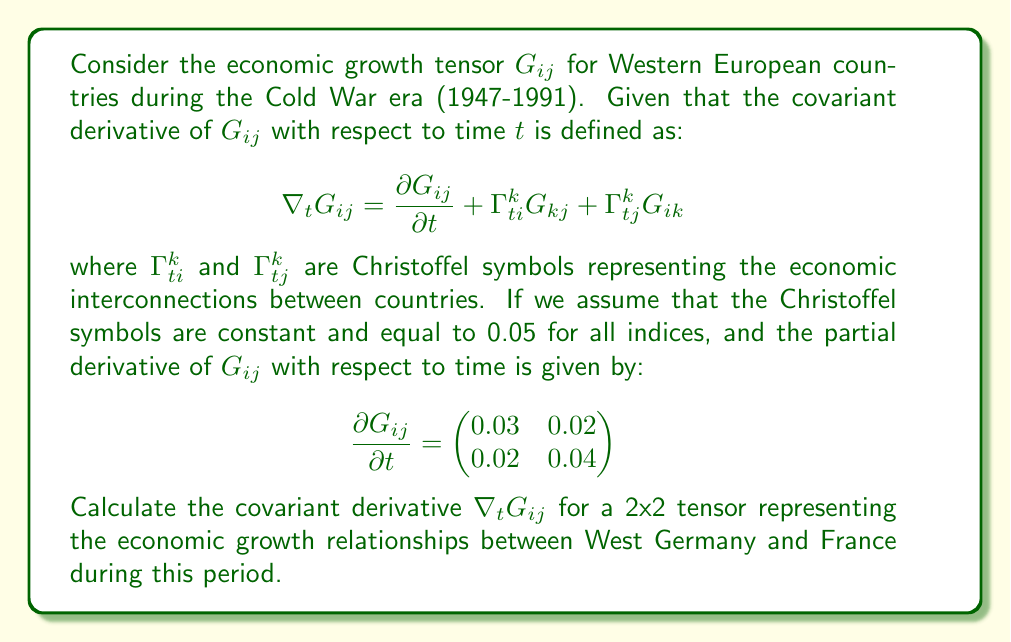Can you answer this question? To solve this problem, we need to follow these steps:

1) We are given the formula for the covariant derivative:

   $$\nabla_t G_{ij} = \frac{\partial G_{ij}}{\partial t} + \Gamma^k_{ti}G_{kj} + \Gamma^k_{tj}G_{ik}$$

2) We know the partial derivative:

   $$\frac{\partial G_{ij}}{\partial t} = \begin{pmatrix} 0.03 & 0.02 \\ 0.02 & 0.04 \end{pmatrix}$$

3) The Christoffel symbols are constant and equal to 0.05 for all indices.

4) We need to calculate $\Gamma^k_{ti}G_{kj}$ and $\Gamma^k_{tj}G_{ik}$:

   For a 2x2 tensor, $k$ can be 1 or 2. So:

   $\Gamma^k_{ti}G_{kj} = 0.05(G_{1j} + G_{2j})$ for each $i$ and $j$
   $\Gamma^k_{tj}G_{ik} = 0.05(G_{i1} + G_{i2})$ for each $i$ and $j$

5) Let's denote the elements of $G_{ij}$ as:

   $$G_{ij} = \begin{pmatrix} a & b \\ c & d \end{pmatrix}$$

6) Now we can calculate each element of $\nabla_t G_{ij}$:

   For $i=1, j=1$: 
   $0.03 + 0.05(a + c) + 0.05(a + b) = 0.03 + 0.05(2a + b + c)$

   For $i=1, j=2$: 
   $0.02 + 0.05(b + d) + 0.05(a + b) = 0.02 + 0.05(a + 2b + d)$

   For $i=2, j=1$: 
   $0.02 + 0.05(a + c) + 0.05(c + d) = 0.02 + 0.05(a + 2c + d)$

   For $i=2, j=2$: 
   $0.04 + 0.05(b + d) + 0.05(c + d) = 0.04 + 0.05(b + c + 2d)$

7) Therefore, the covariant derivative is:

   $$\nabla_t G_{ij} = \begin{pmatrix} 
   0.03 + 0.05(2a + b + c) & 0.02 + 0.05(a + 2b + d) \\
   0.02 + 0.05(a + 2c + d) & 0.04 + 0.05(b + c + 2d)
   \end{pmatrix}$$

This is our final result, expressed in terms of the original tensor elements $a$, $b$, $c$, and $d$.
Answer: $$\nabla_t G_{ij} = \begin{pmatrix} 
0.03 + 0.05(2a + b + c) & 0.02 + 0.05(a + 2b + d) \\
0.02 + 0.05(a + 2c + d) & 0.04 + 0.05(b + c + 2d)
\end{pmatrix}$$ 